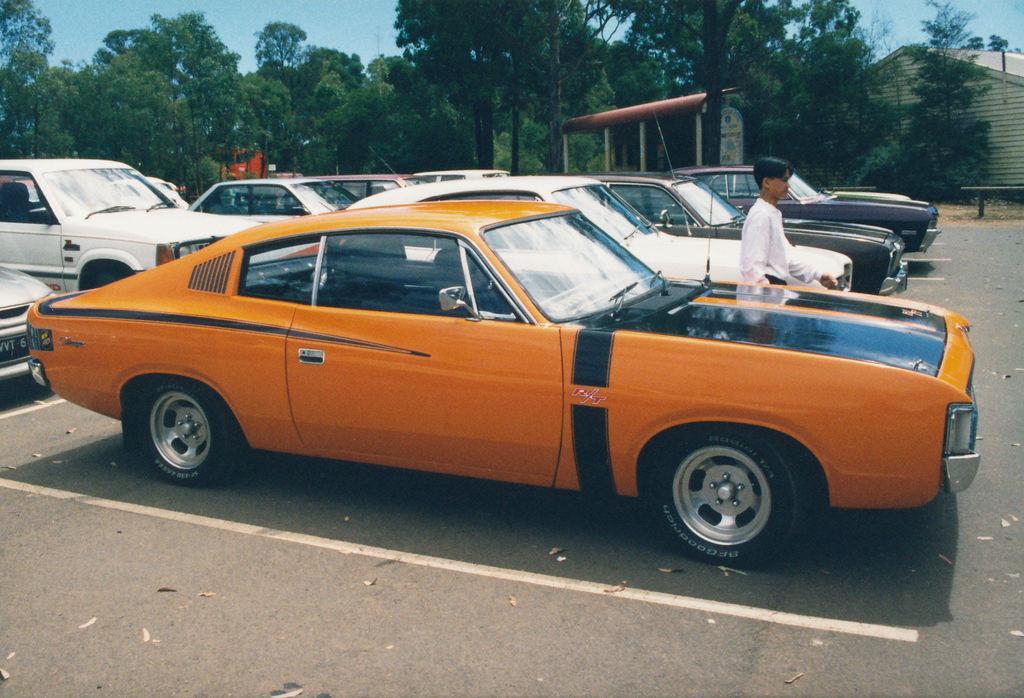Describe this image in one or two sentences. In the center of the image we can see a few vehicles on the road. And we can see one person is standing. In the background, we can see the sky, trees, one house and a few other objects. 